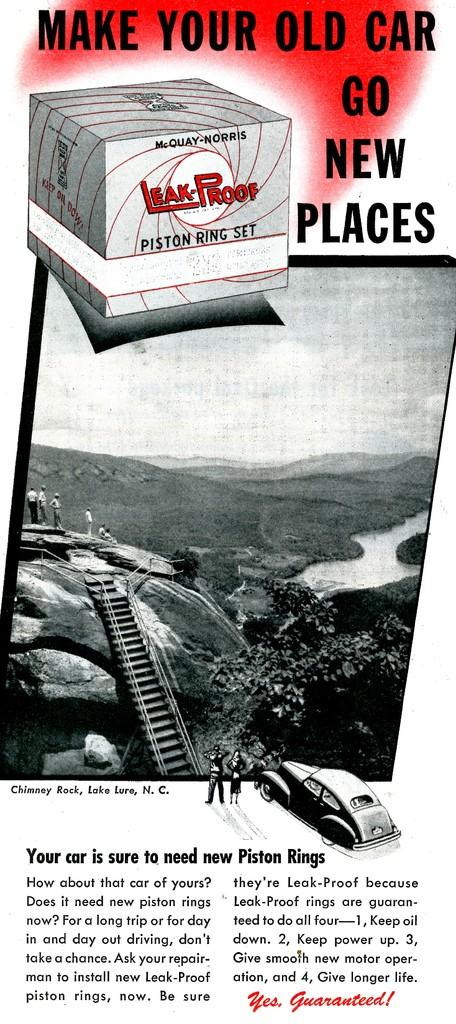<image>
Render a clear and concise summary of the photo. The advertisement is for piston ring replacements for old cars. 